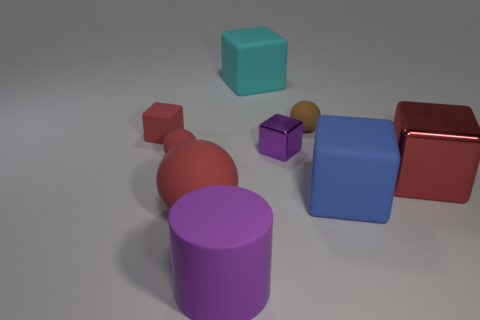There is a matte thing that is the same color as the small metal object; what is its size?
Offer a terse response. Large. There is a cube that is to the left of the big red rubber object; does it have the same color as the ball that is in front of the big red block?
Keep it short and to the point. Yes. What is the color of the small rubber thing that is the same shape as the large blue thing?
Ensure brevity in your answer.  Red. What number of small blocks have the same color as the large cylinder?
Keep it short and to the point. 1. There is a large red thing in front of the big blue cube; are there any cubes that are right of it?
Your answer should be very brief. Yes. How many big rubber objects are both behind the big purple matte object and in front of the big cyan rubber thing?
Offer a terse response. 2. What number of big gray cylinders are made of the same material as the large red sphere?
Give a very brief answer. 0. What size is the brown rubber object that is behind the red object on the right side of the rubber cylinder?
Offer a terse response. Small. Are there any large red matte objects of the same shape as the brown matte object?
Offer a terse response. Yes. There is a cube that is behind the small red matte block; does it have the same size as the red cube that is right of the cyan cube?
Provide a succinct answer. Yes. 